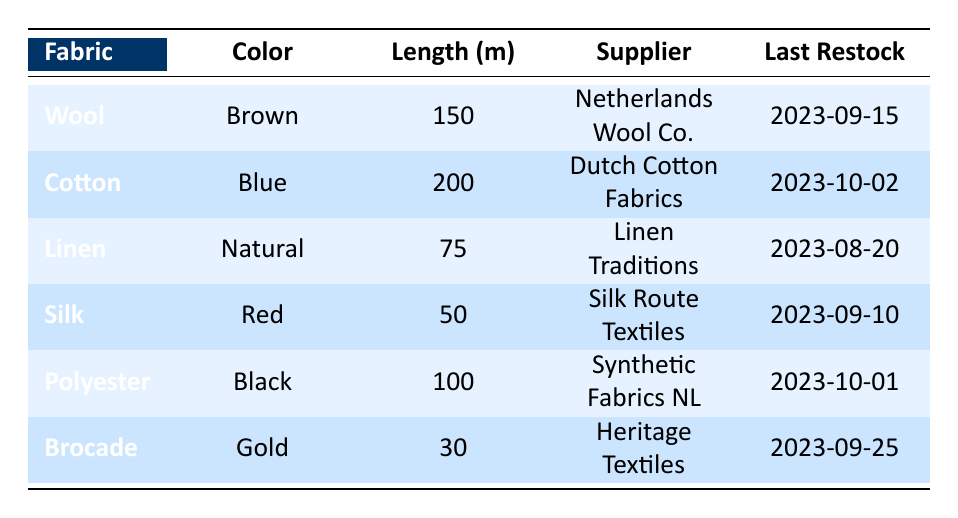What is the available length of Silk fabric? From the table, the Silk fabric has an available length of 50 meters as stated next to the fabric material under the Length column.
Answer: 50 m Which fabric has the most available length? The Cotton fabric has the highest available length of 200 meters, which is the maximum length in the Length column across all fabrics.
Answer: Cotton Is there any fabric available in the color Gold? Yes, there is Brocade fabric available in the color Gold, as indicated in the Color column next to the fabric material.
Answer: Yes What is the total available length of all fabrics combined? To find the total available length, we add the lengths of all fabrics: 150 (Wool) + 200 (Cotton) + 75 (Linen) + 50 (Silk) + 100 (Polyester) + 30 (Brocade) = 605 meters.
Answer: 605 m When was the last restock date for Polyester? The last restock date for Polyester is listed as 2023-10-01 in the Last Restock column next to the Polyester fabric.
Answer: 2023-10-01 Does Linens have a longer length than Brocade? Yes, Linen has an available length of 75 meters while Brocade has only 30 meters, making Linen longer than Brocade.
Answer: Yes Which supplier restocked fabric most recently? The supplier for Cotton, Dutch Cotton Fabrics, restocked on 2023-10-02, which is the most recent date compared to others in the Last Restock column.
Answer: Dutch Cotton Fabrics What is the average available length of all fabrics? The average available length is calculated by summing all available lengths (150 + 200 + 75 + 50 + 100 + 30 = 605) and dividing by the number of fabrics (6), resulting in 605 / 6 = 100.83 meters.
Answer: 100.83 m Is there any fabric from Heritage Textiles? Yes, the Brocade fabric is provided by the Heritage Textiles supplier, as noted in the Supplier column next to the fabric material.
Answer: Yes 